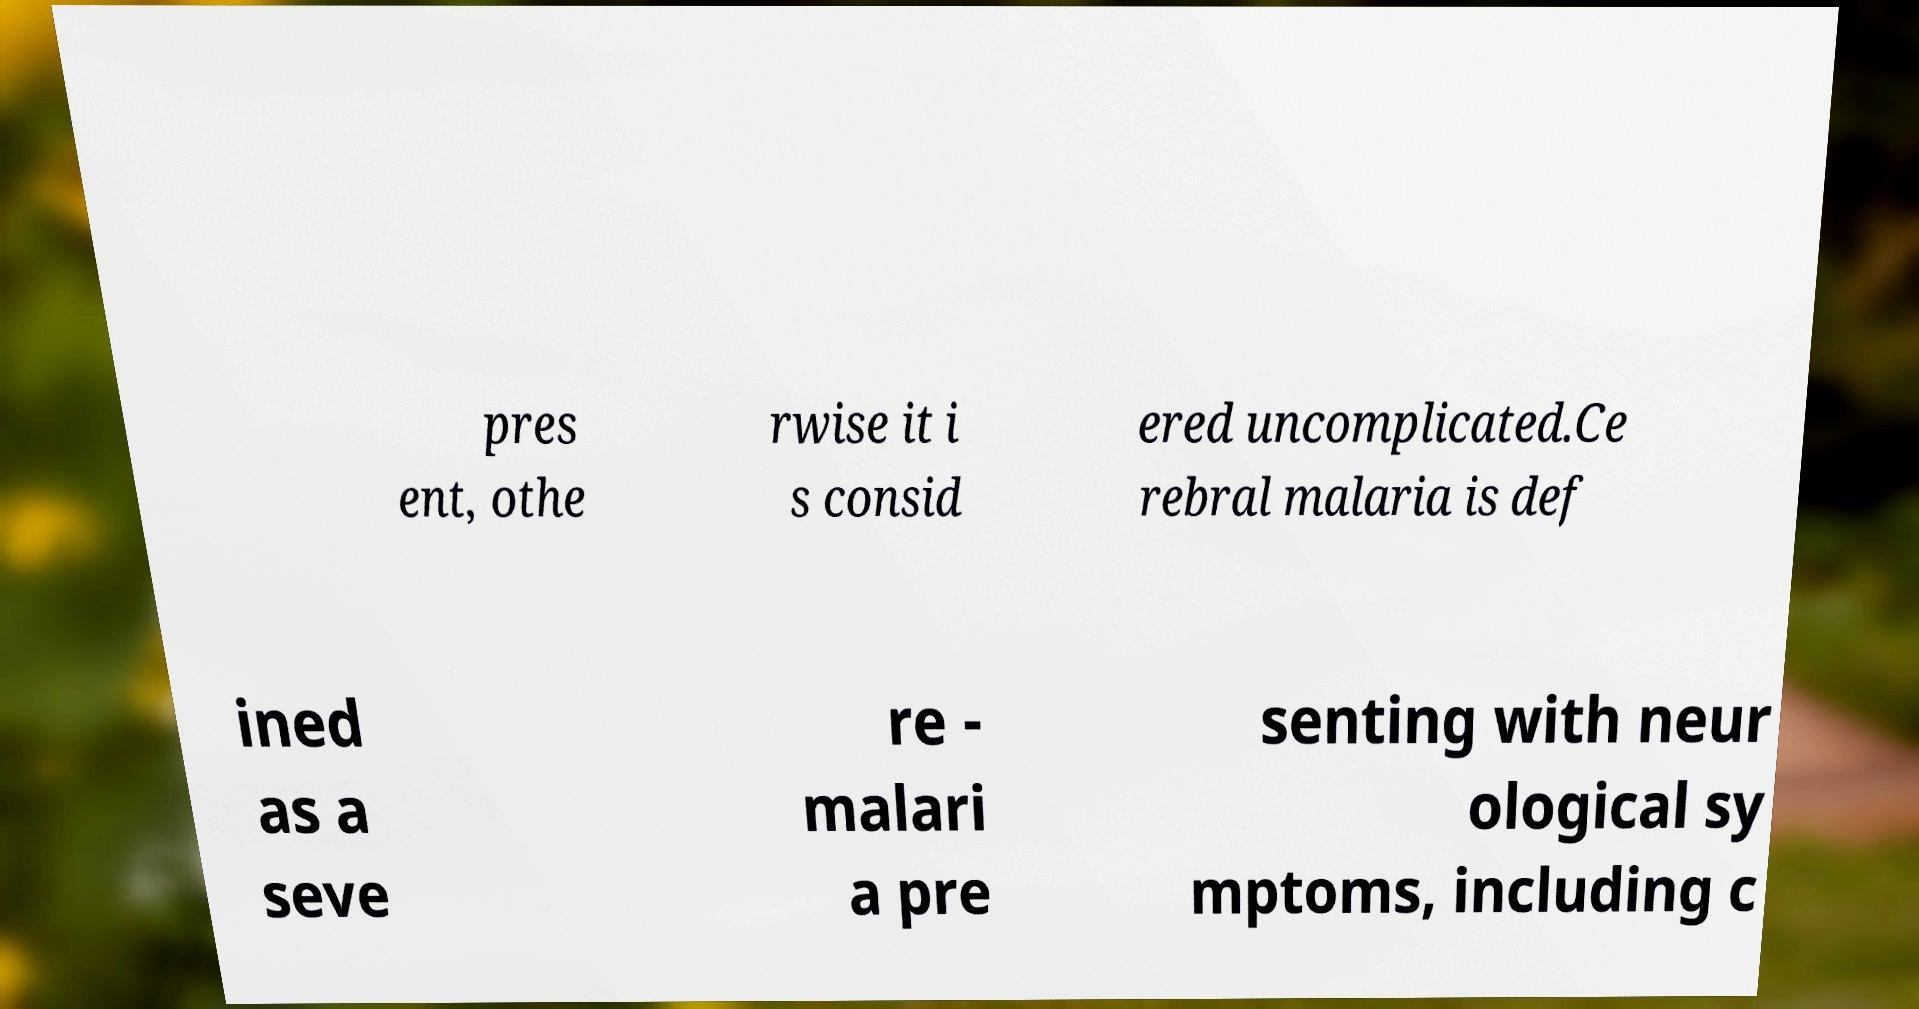For documentation purposes, I need the text within this image transcribed. Could you provide that? pres ent, othe rwise it i s consid ered uncomplicated.Ce rebral malaria is def ined as a seve re - malari a pre senting with neur ological sy mptoms, including c 